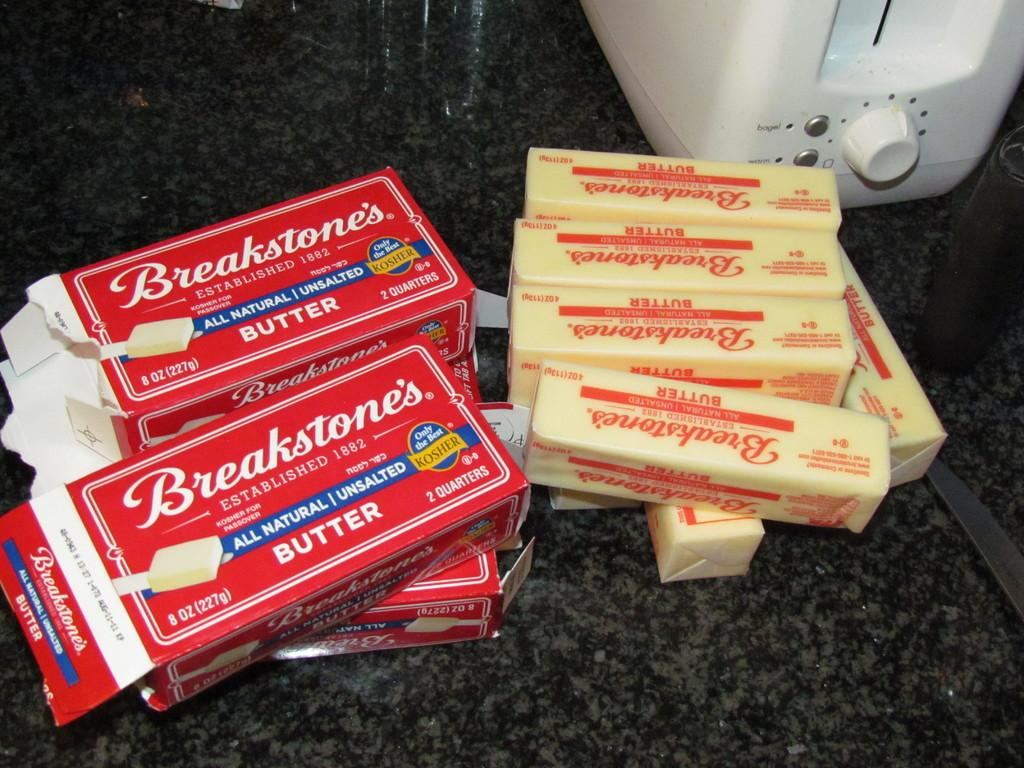<image>
Create a compact narrative representing the image presented. The brand of butter shown is Breakstone's butter 